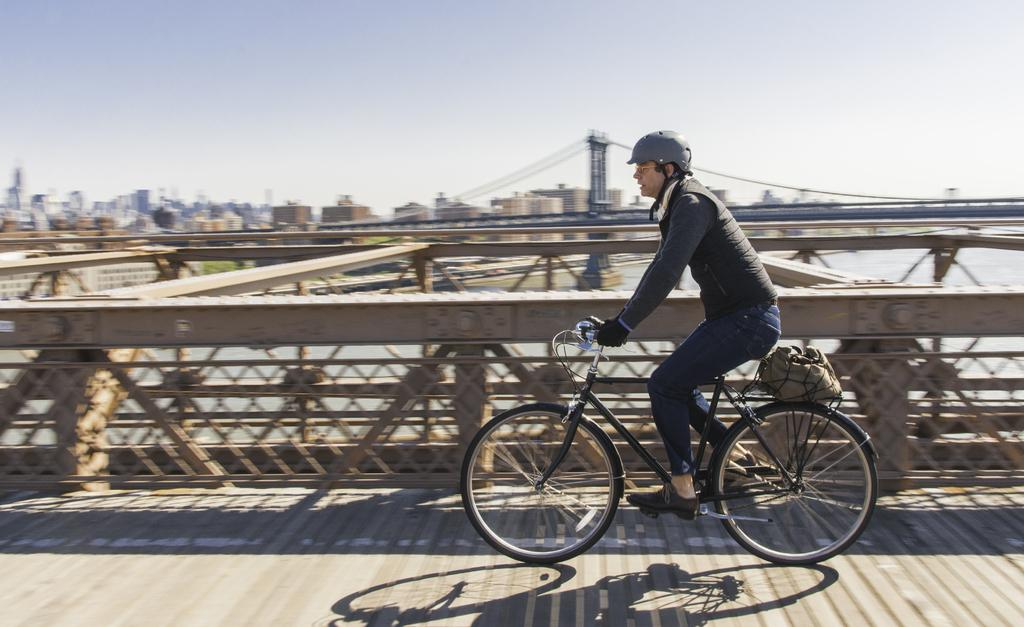Who is the main subject in the image? There is a man in the image. What is the man doing in the image? The man is riding a bicycle. Where is the man located in the image? The man is on a bridge. What can be seen in the background of the image? There are buildings and water visible in the image. What type of dinner is the man eating while riding the bicycle in the image? There is no dinner present in the image; the man is riding a bicycle on a bridge. Can you tell me where the pig is located in the image? There is no pig present in the image. 